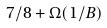<formula> <loc_0><loc_0><loc_500><loc_500>7 / 8 + \Omega ( 1 / B )</formula> 